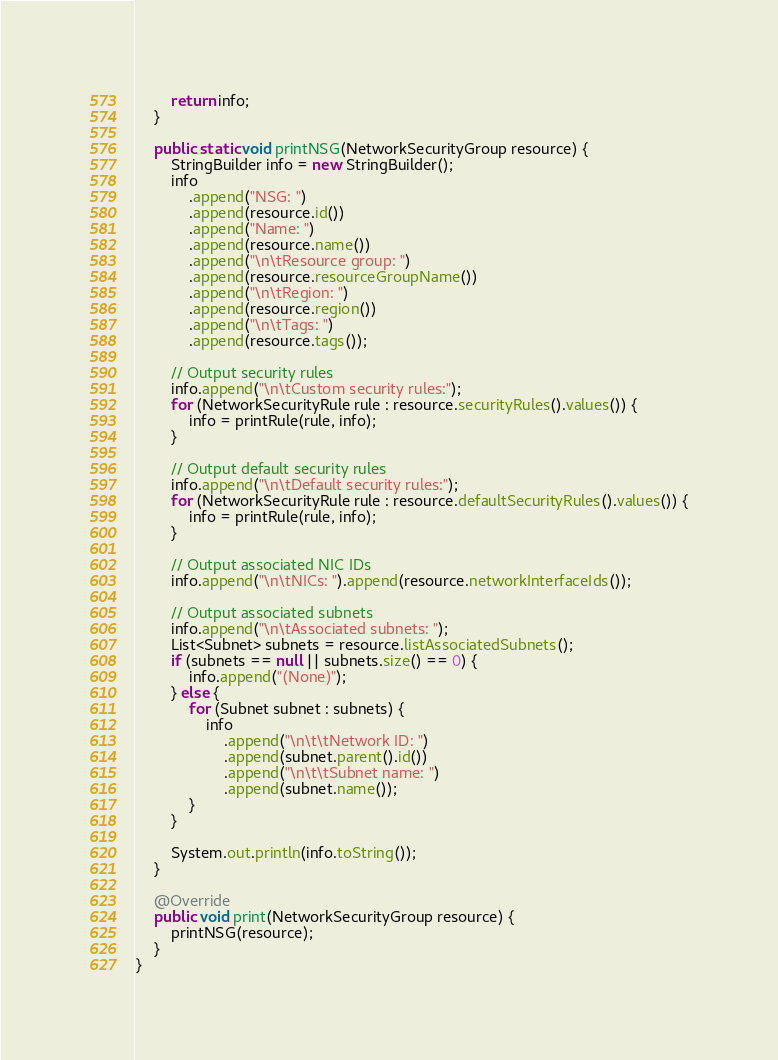Convert code to text. <code><loc_0><loc_0><loc_500><loc_500><_Java_>        return info;
    }

    public static void printNSG(NetworkSecurityGroup resource) {
        StringBuilder info = new StringBuilder();
        info
            .append("NSG: ")
            .append(resource.id())
            .append("Name: ")
            .append(resource.name())
            .append("\n\tResource group: ")
            .append(resource.resourceGroupName())
            .append("\n\tRegion: ")
            .append(resource.region())
            .append("\n\tTags: ")
            .append(resource.tags());

        // Output security rules
        info.append("\n\tCustom security rules:");
        for (NetworkSecurityRule rule : resource.securityRules().values()) {
            info = printRule(rule, info);
        }

        // Output default security rules
        info.append("\n\tDefault security rules:");
        for (NetworkSecurityRule rule : resource.defaultSecurityRules().values()) {
            info = printRule(rule, info);
        }

        // Output associated NIC IDs
        info.append("\n\tNICs: ").append(resource.networkInterfaceIds());

        // Output associated subnets
        info.append("\n\tAssociated subnets: ");
        List<Subnet> subnets = resource.listAssociatedSubnets();
        if (subnets == null || subnets.size() == 0) {
            info.append("(None)");
        } else {
            for (Subnet subnet : subnets) {
                info
                    .append("\n\t\tNetwork ID: ")
                    .append(subnet.parent().id())
                    .append("\n\t\tSubnet name: ")
                    .append(subnet.name());
            }
        }

        System.out.println(info.toString());
    }

    @Override
    public void print(NetworkSecurityGroup resource) {
        printNSG(resource);
    }
}
</code> 